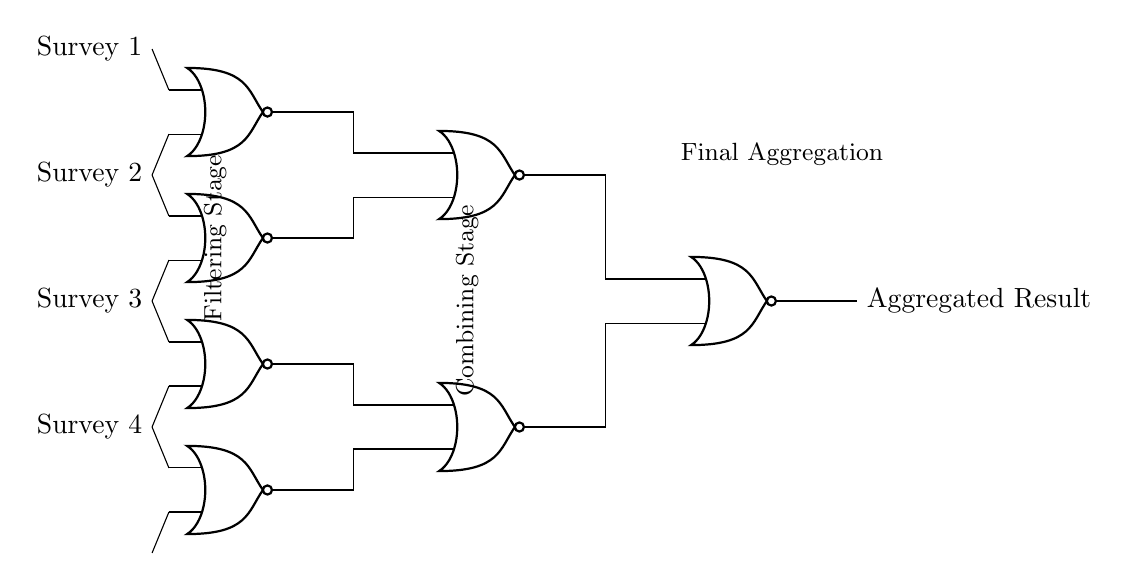What type of gates are used in this circuit? The circuit exclusively uses NOR gates, indicated by the gate symbols shown in the diagram, which are labeled as NOR.
Answer: NOR gates How many input surveys are processed in this circuit? There are four input surveys connected to the NOR gates, as counted from the nodes labeled Survey 1 through Survey 4.
Answer: Four What is the function of the NOR gates in this circuit? The NOR gates filter and combine survey results by outputting high only when all inputs are low, thus performing logical operations for aggregating public opinion.
Answer: Filtering and combining How many stages are there in this circuit? The circuit has two distinct stages: a filtering stage where individual survey results are processed, and a combining stage where filtered results are aggregated into a final output.
Answer: Two What is the output of the final NOR gate? The output of the final NOR gate represents the aggregated result of all the processed survey data, summarizing the filtered outcomes from the previous gates.
Answer: Aggregated result Which NOR gate has Survey 1 as an input? Survey 1 is an input to the first NOR gate, identified as NOR1, which is positioned at the top of the filtering stage in the diagram.
Answer: NOR1 How are the outputs of the filtering NOR gates connected? The outputs of the filtering NOR gates (NOR1 to NOR4) are connected to the inputs of two combining NOR gates (NOR5 and NOR6), allowing for their results to be aggregated into a final output.
Answer: Connected to NOR5 and NOR6 